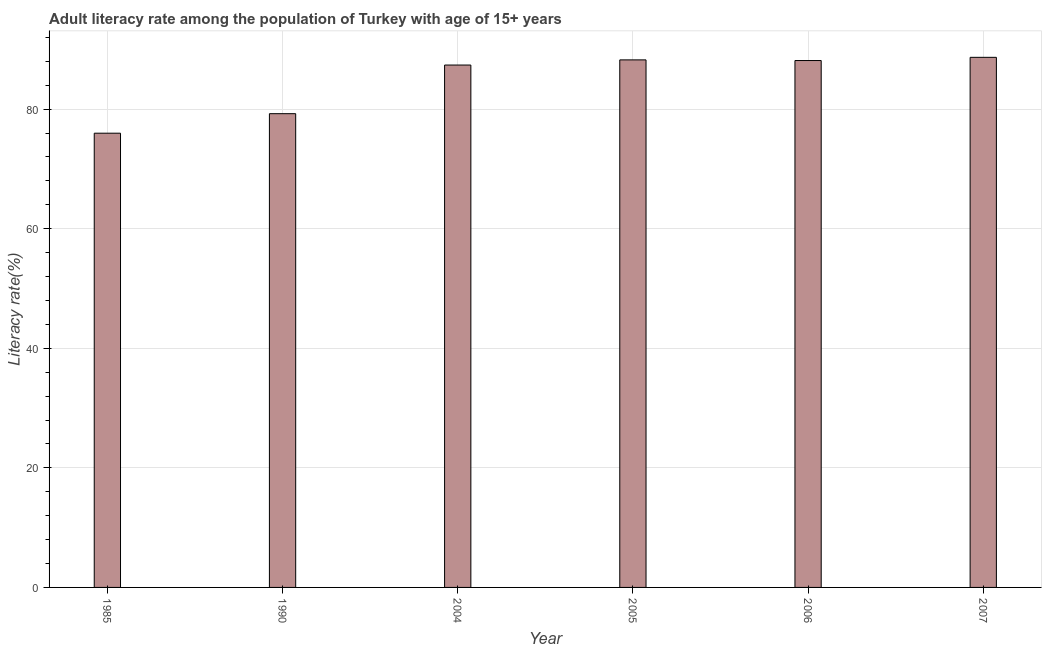Does the graph contain grids?
Your answer should be very brief. Yes. What is the title of the graph?
Offer a terse response. Adult literacy rate among the population of Turkey with age of 15+ years. What is the label or title of the X-axis?
Offer a very short reply. Year. What is the label or title of the Y-axis?
Your answer should be compact. Literacy rate(%). What is the adult literacy rate in 2005?
Offer a terse response. 88.23. Across all years, what is the maximum adult literacy rate?
Your answer should be compact. 88.66. Across all years, what is the minimum adult literacy rate?
Provide a short and direct response. 75.97. What is the sum of the adult literacy rate?
Give a very brief answer. 507.57. What is the difference between the adult literacy rate in 2005 and 2006?
Provide a succinct answer. 0.11. What is the average adult literacy rate per year?
Your response must be concise. 84.59. What is the median adult literacy rate?
Your answer should be compact. 87.74. What is the ratio of the adult literacy rate in 1985 to that in 2006?
Offer a very short reply. 0.86. What is the difference between the highest and the second highest adult literacy rate?
Your answer should be very brief. 0.43. Is the sum of the adult literacy rate in 1990 and 2005 greater than the maximum adult literacy rate across all years?
Offer a terse response. Yes. What is the difference between the highest and the lowest adult literacy rate?
Give a very brief answer. 12.69. In how many years, is the adult literacy rate greater than the average adult literacy rate taken over all years?
Keep it short and to the point. 4. Are all the bars in the graph horizontal?
Offer a terse response. No. How many years are there in the graph?
Offer a very short reply. 6. What is the Literacy rate(%) in 1985?
Your answer should be compact. 75.97. What is the Literacy rate(%) in 1990?
Offer a very short reply. 79.23. What is the Literacy rate(%) in 2004?
Give a very brief answer. 87.37. What is the Literacy rate(%) of 2005?
Provide a short and direct response. 88.23. What is the Literacy rate(%) of 2006?
Your answer should be compact. 88.12. What is the Literacy rate(%) in 2007?
Keep it short and to the point. 88.66. What is the difference between the Literacy rate(%) in 1985 and 1990?
Provide a succinct answer. -3.26. What is the difference between the Literacy rate(%) in 1985 and 2004?
Give a very brief answer. -11.4. What is the difference between the Literacy rate(%) in 1985 and 2005?
Your answer should be compact. -12.26. What is the difference between the Literacy rate(%) in 1985 and 2006?
Provide a short and direct response. -12.15. What is the difference between the Literacy rate(%) in 1985 and 2007?
Offer a terse response. -12.69. What is the difference between the Literacy rate(%) in 1990 and 2004?
Offer a very short reply. -8.13. What is the difference between the Literacy rate(%) in 1990 and 2005?
Ensure brevity in your answer.  -9. What is the difference between the Literacy rate(%) in 1990 and 2006?
Give a very brief answer. -8.89. What is the difference between the Literacy rate(%) in 1990 and 2007?
Offer a terse response. -9.42. What is the difference between the Literacy rate(%) in 2004 and 2005?
Your answer should be very brief. -0.86. What is the difference between the Literacy rate(%) in 2004 and 2006?
Make the answer very short. -0.75. What is the difference between the Literacy rate(%) in 2004 and 2007?
Offer a terse response. -1.29. What is the difference between the Literacy rate(%) in 2005 and 2006?
Give a very brief answer. 0.11. What is the difference between the Literacy rate(%) in 2005 and 2007?
Provide a short and direct response. -0.43. What is the difference between the Literacy rate(%) in 2006 and 2007?
Give a very brief answer. -0.54. What is the ratio of the Literacy rate(%) in 1985 to that in 1990?
Offer a very short reply. 0.96. What is the ratio of the Literacy rate(%) in 1985 to that in 2004?
Provide a succinct answer. 0.87. What is the ratio of the Literacy rate(%) in 1985 to that in 2005?
Make the answer very short. 0.86. What is the ratio of the Literacy rate(%) in 1985 to that in 2006?
Offer a terse response. 0.86. What is the ratio of the Literacy rate(%) in 1985 to that in 2007?
Your answer should be compact. 0.86. What is the ratio of the Literacy rate(%) in 1990 to that in 2004?
Keep it short and to the point. 0.91. What is the ratio of the Literacy rate(%) in 1990 to that in 2005?
Give a very brief answer. 0.9. What is the ratio of the Literacy rate(%) in 1990 to that in 2006?
Your response must be concise. 0.9. What is the ratio of the Literacy rate(%) in 1990 to that in 2007?
Give a very brief answer. 0.89. What is the ratio of the Literacy rate(%) in 2004 to that in 2005?
Keep it short and to the point. 0.99. What is the ratio of the Literacy rate(%) in 2004 to that in 2007?
Provide a short and direct response. 0.98. What is the ratio of the Literacy rate(%) in 2006 to that in 2007?
Keep it short and to the point. 0.99. 